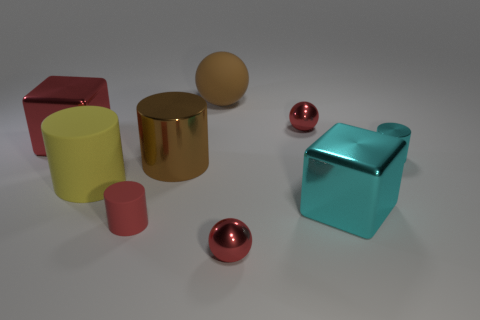Subtract all red rubber cylinders. How many cylinders are left? 3 Add 1 tiny red cubes. How many objects exist? 10 Subtract all yellow cylinders. How many cylinders are left? 3 Subtract all blocks. How many objects are left? 7 Add 1 tiny things. How many tiny things are left? 5 Add 2 large brown things. How many large brown things exist? 4 Subtract 0 gray spheres. How many objects are left? 9 Subtract 2 cubes. How many cubes are left? 0 Subtract all blue spheres. Subtract all gray blocks. How many spheres are left? 3 Subtract all blue blocks. How many brown spheres are left? 1 